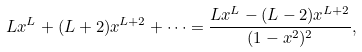Convert formula to latex. <formula><loc_0><loc_0><loc_500><loc_500>L x ^ { L } + ( L + 2 ) x ^ { L + 2 } + \cdots = \frac { L x ^ { L } - ( L - 2 ) x ^ { L + 2 } } { ( 1 - x ^ { 2 } ) ^ { 2 } } ,</formula> 